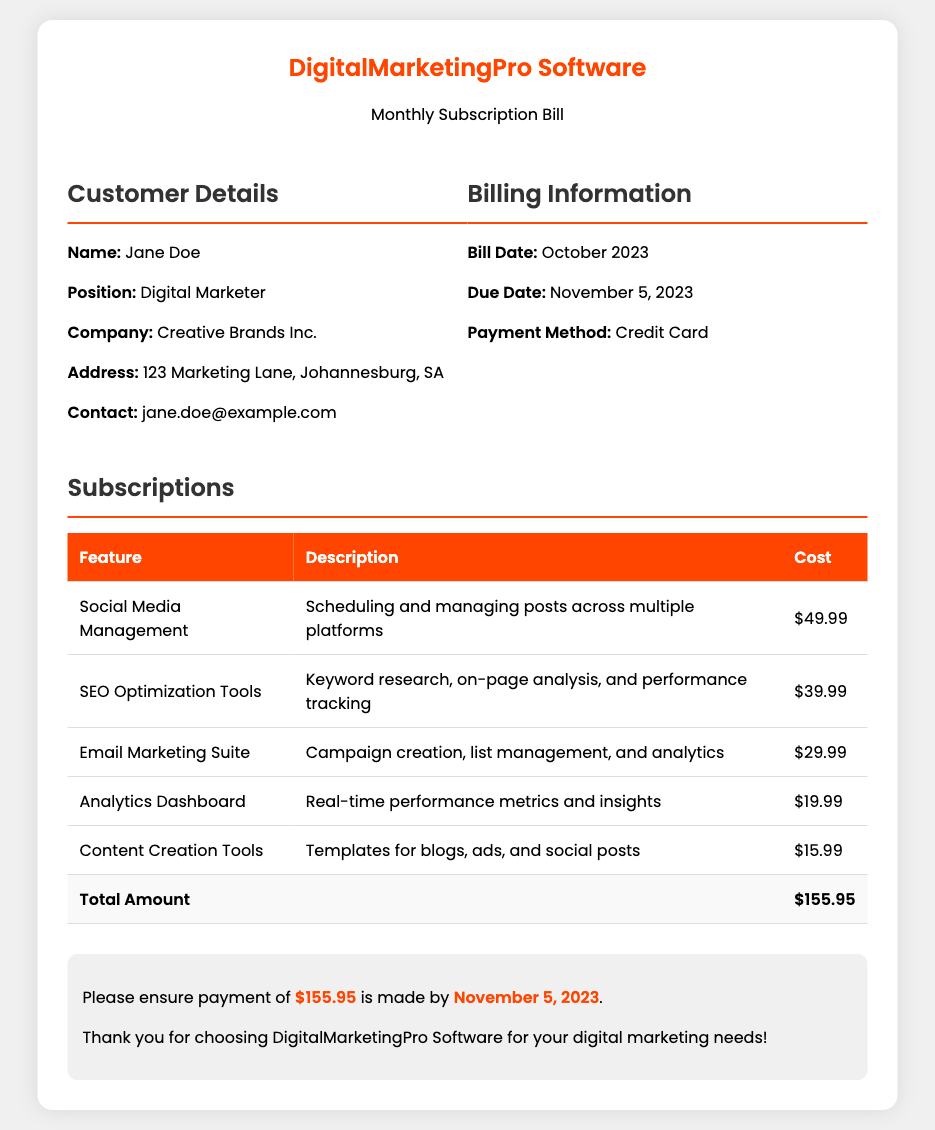what is the total amount due? The total amount due is listed at the bottom of the subscriptions table.
Answer: $155.95 what is the name of the customer? The customer's name is provided in the customer details section.
Answer: Jane Doe what is the due date for the payment? The due date is specified in the billing information section.
Answer: November 5, 2023 how much does the SEO optimization tools feature cost? The cost for the SEO Optimization Tools is provided in the subscription table.
Answer: $39.99 what is the primary function of the Analytics Dashboard feature? The description of the Analytics Dashboard specifies its function.
Answer: Real-time performance metrics and insights how many different features are listed in the bill? The number of features is counted from the subscription table.
Answer: 5 what payment method is being used for the bill? The payment method is mentioned in the billing information section.
Answer: Credit Card which feature has the highest cost? The feature with the highest cost can be determined by comparing the costs listed in the subscription table.
Answer: Social Media Management what is the position of the customer? The customer's position is detailed in the customer info section of the document.
Answer: Digital Marketer 